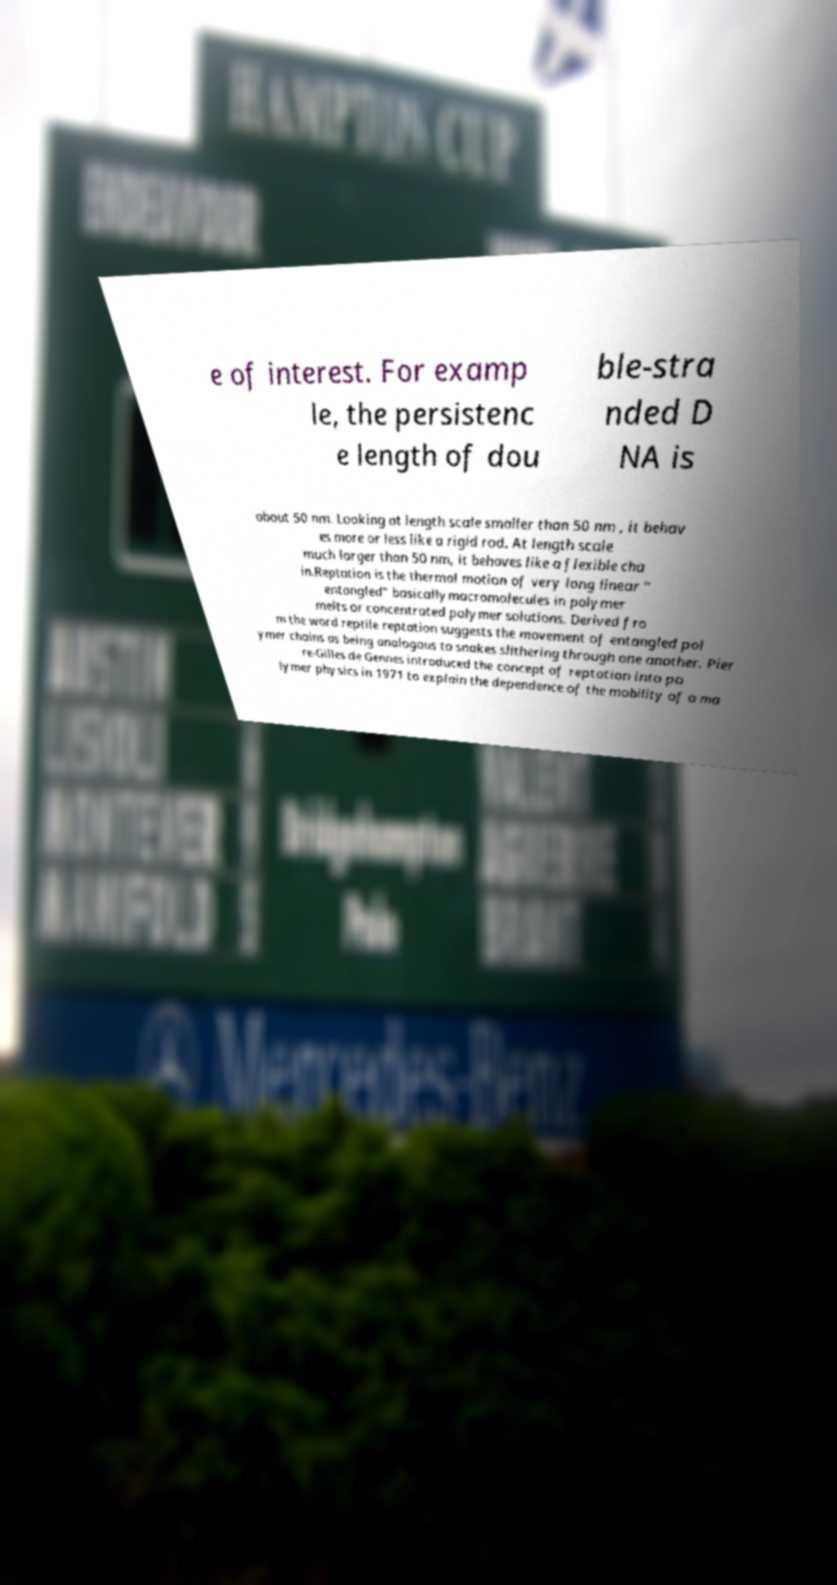What messages or text are displayed in this image? I need them in a readable, typed format. e of interest. For examp le, the persistenc e length of dou ble-stra nded D NA is about 50 nm. Looking at length scale smaller than 50 nm , it behav es more or less like a rigid rod. At length scale much larger than 50 nm, it behaves like a flexible cha in.Reptation is the thermal motion of very long linear " entangled" basicallymacromolecules in polymer melts or concentrated polymer solutions. Derived fro m the word reptile reptation suggests the movement of entangled pol ymer chains as being analogous to snakes slithering through one another. Pier re-Gilles de Gennes introduced the concept of reptation into po lymer physics in 1971 to explain the dependence of the mobility of a ma 